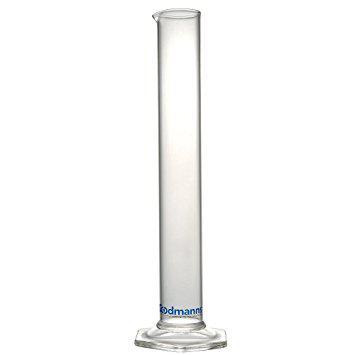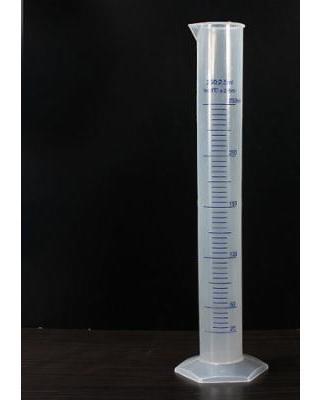The first image is the image on the left, the second image is the image on the right. Assess this claim about the two images: "Each image includes at least one slender test tube-shaped cylinder that stands on a flat hexagon-shaped base.". Correct or not? Answer yes or no. Yes. The first image is the image on the left, the second image is the image on the right. Assess this claim about the two images: "There is one cylinder and three beakers.". Correct or not? Answer yes or no. No. 